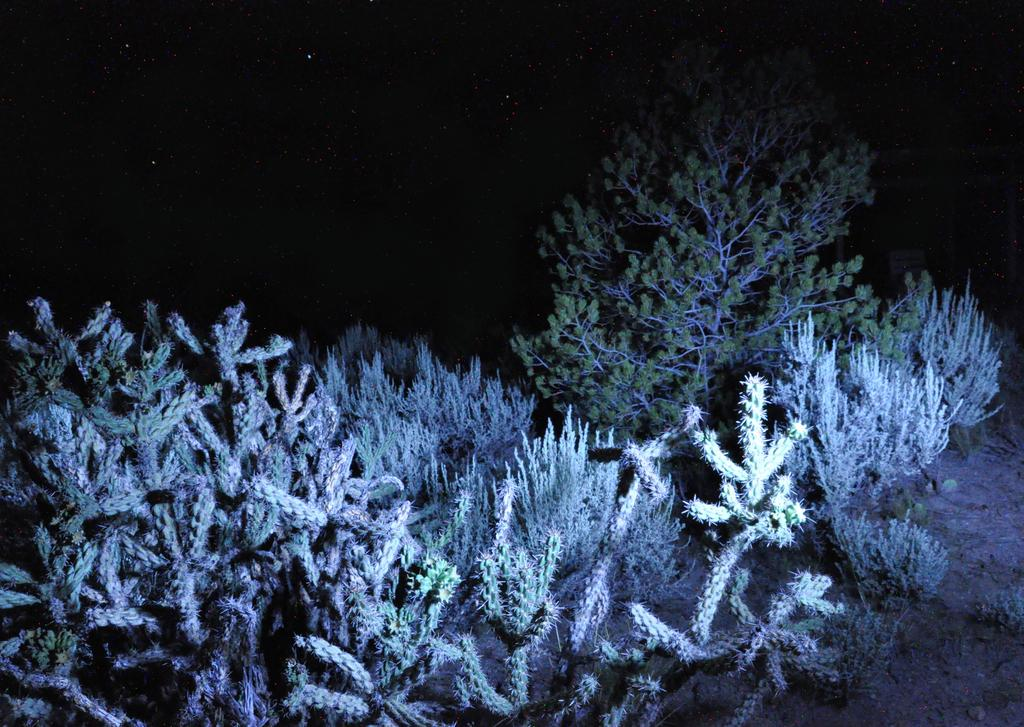What type of plants are in the image? There are cactus plants in the image. What other types of vegetation are in the image? There are small trees in the image. What can be seen in the sky in the image? Stars are visible in the sky in the image. Can you tell me how many pets are visible in the image? There are no pets present in the image. What type of lift is available for the cactus plants in the image? There is no lift present in the image, and cactus plants do not require lifts. 